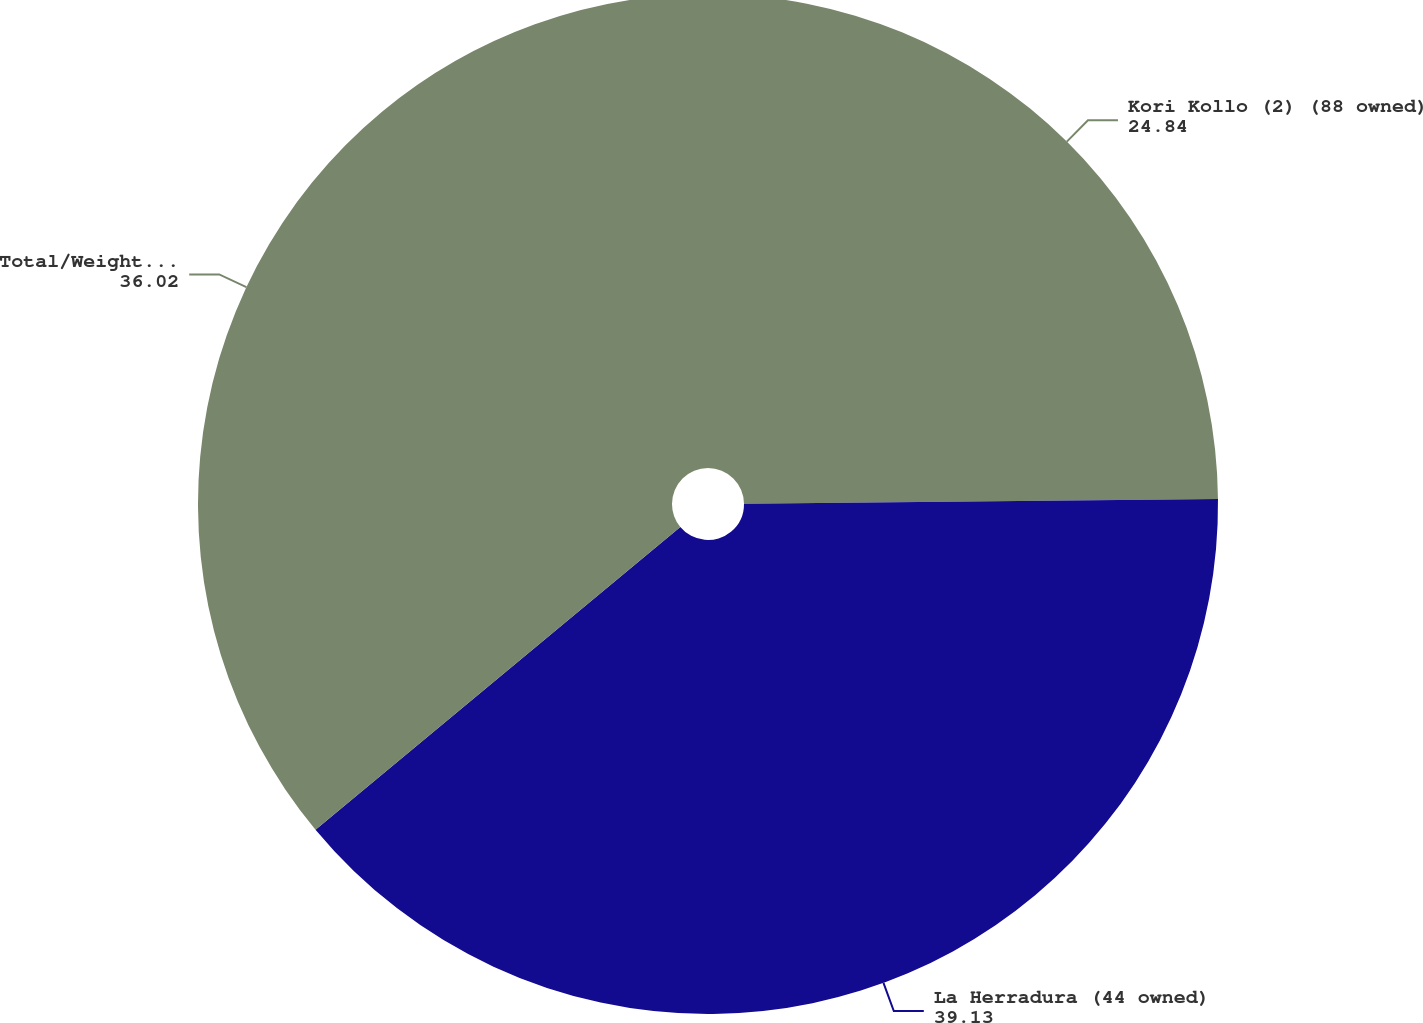Convert chart to OTSL. <chart><loc_0><loc_0><loc_500><loc_500><pie_chart><fcel>Kori Kollo (2) (88 owned)<fcel>La Herradura (44 owned)<fcel>Total/Weighted-Average<nl><fcel>24.84%<fcel>39.13%<fcel>36.02%<nl></chart> 